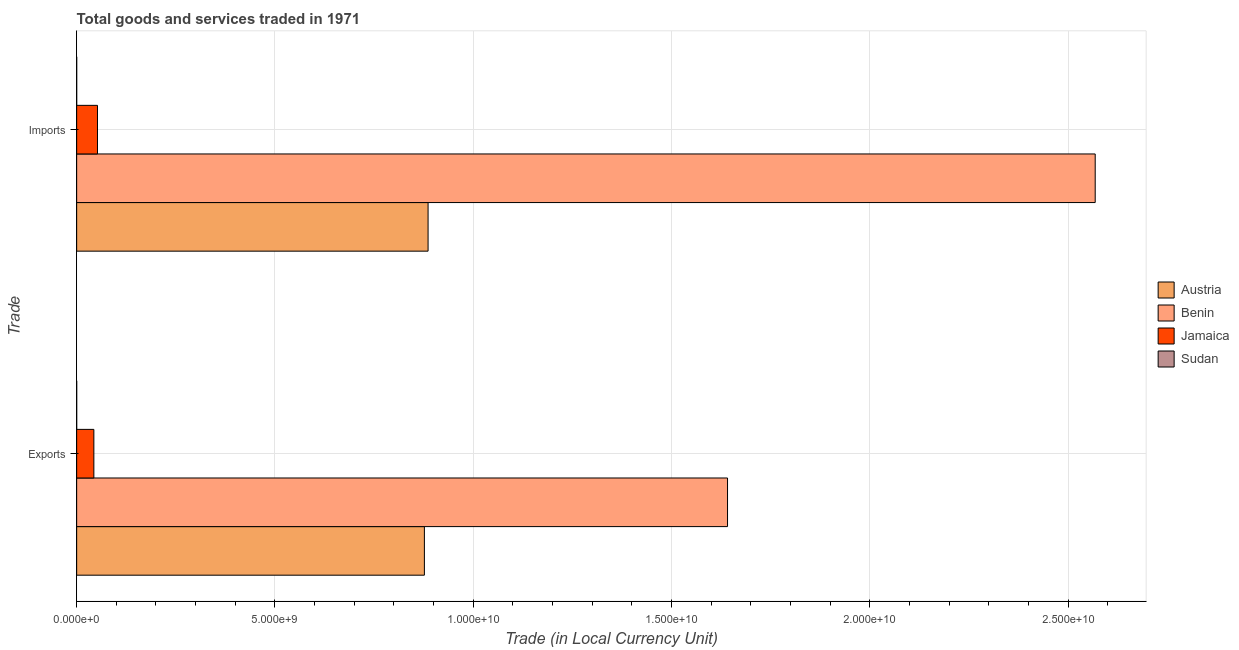How many different coloured bars are there?
Your answer should be compact. 4. How many groups of bars are there?
Give a very brief answer. 2. Are the number of bars per tick equal to the number of legend labels?
Your answer should be compact. Yes. How many bars are there on the 1st tick from the top?
Give a very brief answer. 4. How many bars are there on the 2nd tick from the bottom?
Your answer should be very brief. 4. What is the label of the 1st group of bars from the top?
Provide a short and direct response. Imports. What is the export of goods and services in Jamaica?
Give a very brief answer. 4.34e+08. Across all countries, what is the maximum export of goods and services?
Provide a succinct answer. 1.64e+1. Across all countries, what is the minimum export of goods and services?
Your answer should be compact. 1.25e+05. In which country was the imports of goods and services maximum?
Your answer should be very brief. Benin. In which country was the export of goods and services minimum?
Your answer should be very brief. Sudan. What is the total export of goods and services in the graph?
Offer a very short reply. 2.56e+1. What is the difference between the export of goods and services in Jamaica and that in Benin?
Offer a very short reply. -1.60e+1. What is the difference between the export of goods and services in Austria and the imports of goods and services in Benin?
Your answer should be very brief. -1.69e+1. What is the average imports of goods and services per country?
Give a very brief answer. 8.77e+09. What is the difference between the export of goods and services and imports of goods and services in Benin?
Your answer should be very brief. -9.27e+09. What is the ratio of the export of goods and services in Jamaica to that in Benin?
Offer a very short reply. 0.03. Is the imports of goods and services in Jamaica less than that in Benin?
Make the answer very short. Yes. In how many countries, is the export of goods and services greater than the average export of goods and services taken over all countries?
Keep it short and to the point. 2. What does the 2nd bar from the top in Exports represents?
Make the answer very short. Jamaica. What does the 2nd bar from the bottom in Exports represents?
Keep it short and to the point. Benin. Are all the bars in the graph horizontal?
Offer a very short reply. Yes. What is the difference between two consecutive major ticks on the X-axis?
Provide a short and direct response. 5.00e+09. Where does the legend appear in the graph?
Your response must be concise. Center right. How many legend labels are there?
Ensure brevity in your answer.  4. What is the title of the graph?
Give a very brief answer. Total goods and services traded in 1971. Does "Trinidad and Tobago" appear as one of the legend labels in the graph?
Your response must be concise. No. What is the label or title of the X-axis?
Provide a short and direct response. Trade (in Local Currency Unit). What is the label or title of the Y-axis?
Offer a terse response. Trade. What is the Trade (in Local Currency Unit) in Austria in Exports?
Your response must be concise. 8.77e+09. What is the Trade (in Local Currency Unit) of Benin in Exports?
Your answer should be very brief. 1.64e+1. What is the Trade (in Local Currency Unit) in Jamaica in Exports?
Offer a very short reply. 4.34e+08. What is the Trade (in Local Currency Unit) of Sudan in Exports?
Provide a short and direct response. 1.25e+05. What is the Trade (in Local Currency Unit) of Austria in Imports?
Offer a very short reply. 8.86e+09. What is the Trade (in Local Currency Unit) of Benin in Imports?
Your response must be concise. 2.57e+1. What is the Trade (in Local Currency Unit) of Jamaica in Imports?
Provide a succinct answer. 5.25e+08. What is the Trade (in Local Currency Unit) in Sudan in Imports?
Offer a terse response. 1.37e+05. Across all Trade, what is the maximum Trade (in Local Currency Unit) in Austria?
Offer a very short reply. 8.86e+09. Across all Trade, what is the maximum Trade (in Local Currency Unit) of Benin?
Your answer should be very brief. 2.57e+1. Across all Trade, what is the maximum Trade (in Local Currency Unit) of Jamaica?
Make the answer very short. 5.25e+08. Across all Trade, what is the maximum Trade (in Local Currency Unit) in Sudan?
Offer a very short reply. 1.37e+05. Across all Trade, what is the minimum Trade (in Local Currency Unit) of Austria?
Your answer should be compact. 8.77e+09. Across all Trade, what is the minimum Trade (in Local Currency Unit) in Benin?
Your answer should be compact. 1.64e+1. Across all Trade, what is the minimum Trade (in Local Currency Unit) of Jamaica?
Give a very brief answer. 4.34e+08. Across all Trade, what is the minimum Trade (in Local Currency Unit) in Sudan?
Offer a very short reply. 1.25e+05. What is the total Trade (in Local Currency Unit) in Austria in the graph?
Your answer should be very brief. 1.76e+1. What is the total Trade (in Local Currency Unit) in Benin in the graph?
Make the answer very short. 4.21e+1. What is the total Trade (in Local Currency Unit) of Jamaica in the graph?
Ensure brevity in your answer.  9.59e+08. What is the total Trade (in Local Currency Unit) of Sudan in the graph?
Keep it short and to the point. 2.62e+05. What is the difference between the Trade (in Local Currency Unit) in Austria in Exports and that in Imports?
Your answer should be compact. -9.30e+07. What is the difference between the Trade (in Local Currency Unit) in Benin in Exports and that in Imports?
Make the answer very short. -9.27e+09. What is the difference between the Trade (in Local Currency Unit) in Jamaica in Exports and that in Imports?
Offer a very short reply. -9.13e+07. What is the difference between the Trade (in Local Currency Unit) of Sudan in Exports and that in Imports?
Provide a short and direct response. -1.23e+04. What is the difference between the Trade (in Local Currency Unit) in Austria in Exports and the Trade (in Local Currency Unit) in Benin in Imports?
Your answer should be compact. -1.69e+1. What is the difference between the Trade (in Local Currency Unit) of Austria in Exports and the Trade (in Local Currency Unit) of Jamaica in Imports?
Your answer should be compact. 8.24e+09. What is the difference between the Trade (in Local Currency Unit) in Austria in Exports and the Trade (in Local Currency Unit) in Sudan in Imports?
Offer a very short reply. 8.77e+09. What is the difference between the Trade (in Local Currency Unit) in Benin in Exports and the Trade (in Local Currency Unit) in Jamaica in Imports?
Your answer should be compact. 1.59e+1. What is the difference between the Trade (in Local Currency Unit) of Benin in Exports and the Trade (in Local Currency Unit) of Sudan in Imports?
Give a very brief answer. 1.64e+1. What is the difference between the Trade (in Local Currency Unit) in Jamaica in Exports and the Trade (in Local Currency Unit) in Sudan in Imports?
Provide a succinct answer. 4.34e+08. What is the average Trade (in Local Currency Unit) of Austria per Trade?
Offer a terse response. 8.81e+09. What is the average Trade (in Local Currency Unit) of Benin per Trade?
Offer a very short reply. 2.10e+1. What is the average Trade (in Local Currency Unit) of Jamaica per Trade?
Your answer should be very brief. 4.79e+08. What is the average Trade (in Local Currency Unit) of Sudan per Trade?
Offer a very short reply. 1.31e+05. What is the difference between the Trade (in Local Currency Unit) of Austria and Trade (in Local Currency Unit) of Benin in Exports?
Provide a succinct answer. -7.64e+09. What is the difference between the Trade (in Local Currency Unit) in Austria and Trade (in Local Currency Unit) in Jamaica in Exports?
Your answer should be very brief. 8.33e+09. What is the difference between the Trade (in Local Currency Unit) of Austria and Trade (in Local Currency Unit) of Sudan in Exports?
Give a very brief answer. 8.77e+09. What is the difference between the Trade (in Local Currency Unit) of Benin and Trade (in Local Currency Unit) of Jamaica in Exports?
Your answer should be compact. 1.60e+1. What is the difference between the Trade (in Local Currency Unit) of Benin and Trade (in Local Currency Unit) of Sudan in Exports?
Give a very brief answer. 1.64e+1. What is the difference between the Trade (in Local Currency Unit) of Jamaica and Trade (in Local Currency Unit) of Sudan in Exports?
Offer a very short reply. 4.34e+08. What is the difference between the Trade (in Local Currency Unit) in Austria and Trade (in Local Currency Unit) in Benin in Imports?
Offer a very short reply. -1.68e+1. What is the difference between the Trade (in Local Currency Unit) of Austria and Trade (in Local Currency Unit) of Jamaica in Imports?
Provide a short and direct response. 8.33e+09. What is the difference between the Trade (in Local Currency Unit) in Austria and Trade (in Local Currency Unit) in Sudan in Imports?
Your response must be concise. 8.86e+09. What is the difference between the Trade (in Local Currency Unit) in Benin and Trade (in Local Currency Unit) in Jamaica in Imports?
Your answer should be very brief. 2.52e+1. What is the difference between the Trade (in Local Currency Unit) of Benin and Trade (in Local Currency Unit) of Sudan in Imports?
Give a very brief answer. 2.57e+1. What is the difference between the Trade (in Local Currency Unit) of Jamaica and Trade (in Local Currency Unit) of Sudan in Imports?
Offer a very short reply. 5.25e+08. What is the ratio of the Trade (in Local Currency Unit) in Austria in Exports to that in Imports?
Give a very brief answer. 0.99. What is the ratio of the Trade (in Local Currency Unit) of Benin in Exports to that in Imports?
Provide a succinct answer. 0.64. What is the ratio of the Trade (in Local Currency Unit) in Jamaica in Exports to that in Imports?
Your response must be concise. 0.83. What is the ratio of the Trade (in Local Currency Unit) in Sudan in Exports to that in Imports?
Provide a succinct answer. 0.91. What is the difference between the highest and the second highest Trade (in Local Currency Unit) of Austria?
Give a very brief answer. 9.30e+07. What is the difference between the highest and the second highest Trade (in Local Currency Unit) in Benin?
Keep it short and to the point. 9.27e+09. What is the difference between the highest and the second highest Trade (in Local Currency Unit) of Jamaica?
Give a very brief answer. 9.13e+07. What is the difference between the highest and the second highest Trade (in Local Currency Unit) of Sudan?
Offer a terse response. 1.23e+04. What is the difference between the highest and the lowest Trade (in Local Currency Unit) of Austria?
Ensure brevity in your answer.  9.30e+07. What is the difference between the highest and the lowest Trade (in Local Currency Unit) of Benin?
Your answer should be compact. 9.27e+09. What is the difference between the highest and the lowest Trade (in Local Currency Unit) in Jamaica?
Your response must be concise. 9.13e+07. What is the difference between the highest and the lowest Trade (in Local Currency Unit) of Sudan?
Ensure brevity in your answer.  1.23e+04. 